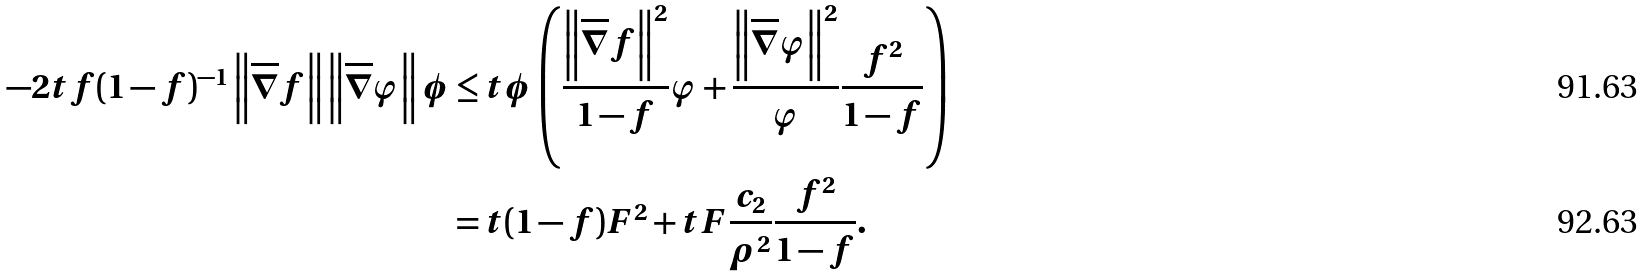Convert formula to latex. <formula><loc_0><loc_0><loc_500><loc_500>- 2 t f ( 1 - f ) ^ { - 1 } \left \| \overline { \nabla } f \right \| \left \| \overline { \nabla } \varphi \right \| \phi & \leq t \phi \left ( \frac { \left \| \overline { \nabla } f \right \| ^ { 2 } } { 1 - f } \varphi + \frac { \left \| \overline { \nabla } \varphi \right \| ^ { 2 } } { \varphi } \frac { f ^ { 2 } } { 1 - f } \right ) \\ & = t ( 1 - f ) F ^ { 2 } + t F \frac { c _ { 2 } } { \rho ^ { 2 } } \frac { f ^ { 2 } } { 1 - f } .</formula> 